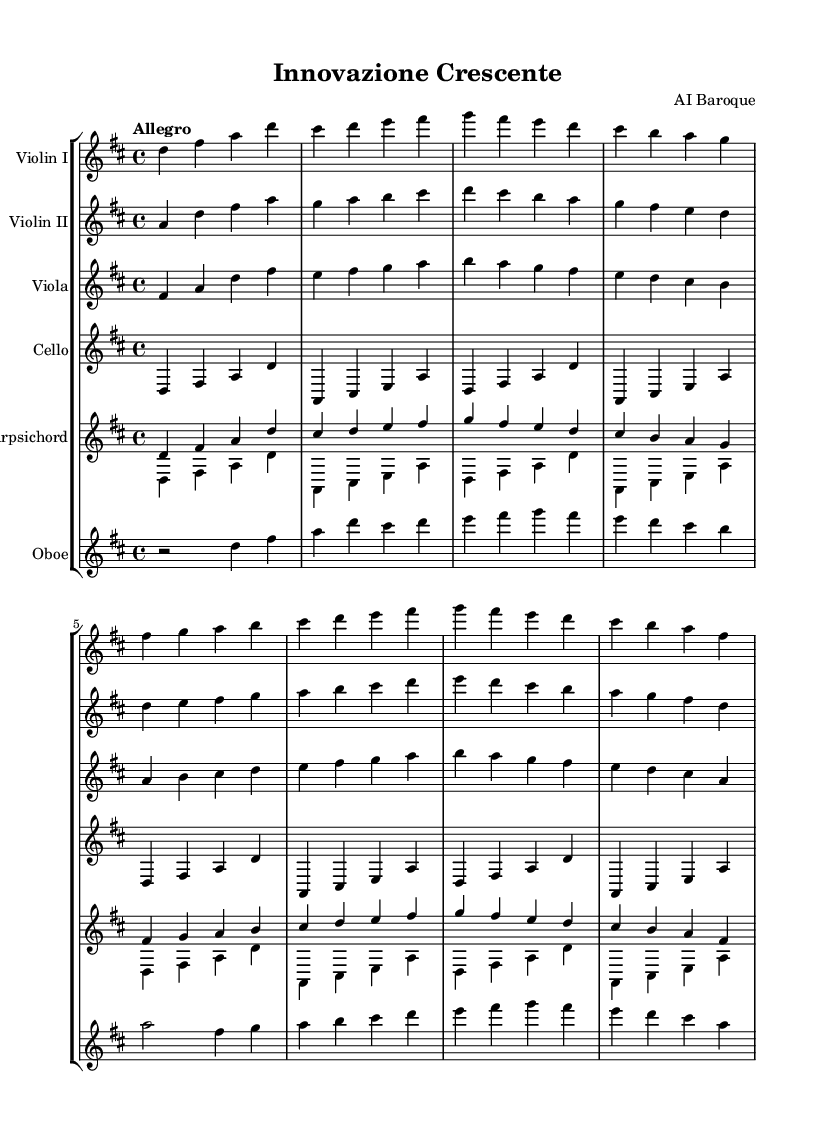What is the key signature of this music? The key signature is D major, which has two sharps (F# and C#). We can determine this by looking at the key signature indicated at the beginning of the sheet music.
Answer: D major What is the time signature of this piece? The time signature is 4/4, which means there are four beats in each measure and the quarter note gets one beat. This is indicated at the beginning where the time signature is shown.
Answer: 4/4 What is the tempo marking for this composition? The tempo marking is "Allegro," which suggests a lively and fast pace. This is indicated in the tempo section at the beginning of the score.
Answer: Allegro Which instruments are featured in this orchestral piece? The piece features Violin I, Violin II, Viola, Cello, Harpsichord, and Oboe. This can be referenced from the staff labels in the score that identify each instrument.
Answer: Violin I, Violin II, Viola, Cello, Harpsichord, Oboe How many measures are in the excerpt provided? There are 16 measures in the excerpt. This can be counted by observing the distinct measure lines that separate each group of notes.
Answer: 16 What is the harmonic progression indicated in the first two measures? The harmonic progression in the first two measures is based on the D major chord (D-F#-A) moving to a B minor chord (B-D-F#). We analyze the notes shown in the measures to identify the chords being played.
Answer: D major to B minor Identify the primary theme presented in the violins. The primary theme presented in the violins consists of an ascending melodic line starting on D and moving to higher notes. This is determined by analyzing the melodic contour shown in the violin staves.
Answer: Ascending melodic line 